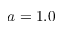Convert formula to latex. <formula><loc_0><loc_0><loc_500><loc_500>a = 1 . 0</formula> 